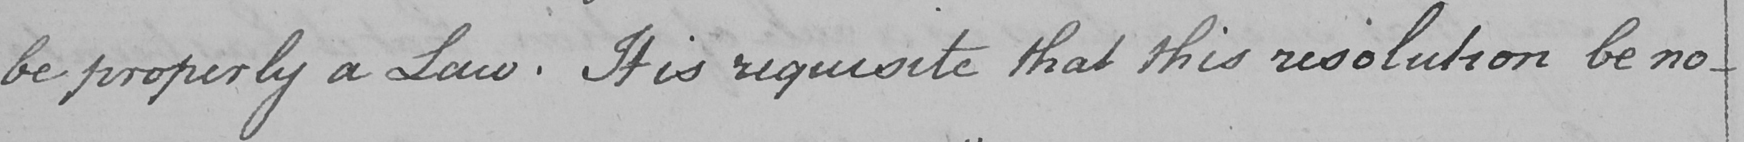What does this handwritten line say? be properly a Law . It is requisite that this resolution be no- 